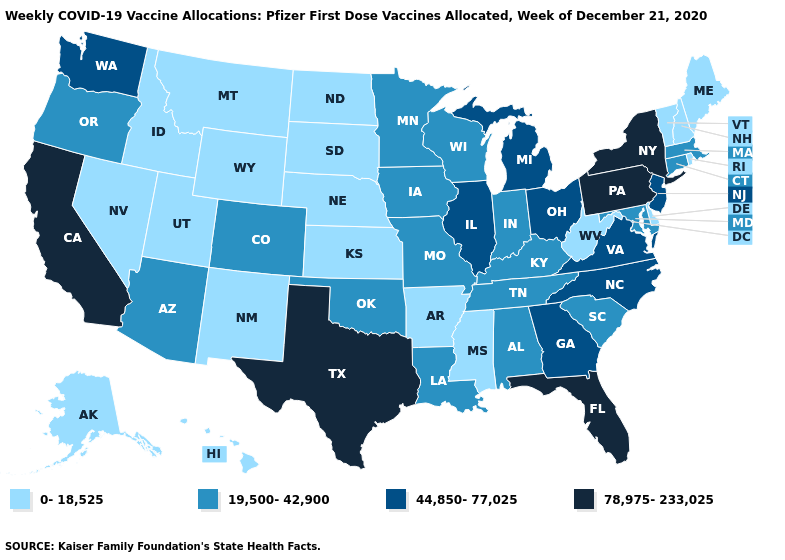How many symbols are there in the legend?
Concise answer only. 4. Name the states that have a value in the range 0-18,525?
Quick response, please. Alaska, Arkansas, Delaware, Hawaii, Idaho, Kansas, Maine, Mississippi, Montana, Nebraska, Nevada, New Hampshire, New Mexico, North Dakota, Rhode Island, South Dakota, Utah, Vermont, West Virginia, Wyoming. Does North Dakota have the highest value in the USA?
Write a very short answer. No. Does Alabama have a higher value than Massachusetts?
Answer briefly. No. Name the states that have a value in the range 19,500-42,900?
Give a very brief answer. Alabama, Arizona, Colorado, Connecticut, Indiana, Iowa, Kentucky, Louisiana, Maryland, Massachusetts, Minnesota, Missouri, Oklahoma, Oregon, South Carolina, Tennessee, Wisconsin. What is the value of Virginia?
Be succinct. 44,850-77,025. What is the value of Illinois?
Be succinct. 44,850-77,025. Does Connecticut have the lowest value in the USA?
Give a very brief answer. No. What is the value of Oregon?
Answer briefly. 19,500-42,900. What is the value of Mississippi?
Short answer required. 0-18,525. Among the states that border Mississippi , does Arkansas have the highest value?
Be succinct. No. Among the states that border Wyoming , does Colorado have the highest value?
Be succinct. Yes. What is the highest value in the USA?
Concise answer only. 78,975-233,025. Does Ohio have the lowest value in the USA?
Be succinct. No. Name the states that have a value in the range 44,850-77,025?
Be succinct. Georgia, Illinois, Michigan, New Jersey, North Carolina, Ohio, Virginia, Washington. 